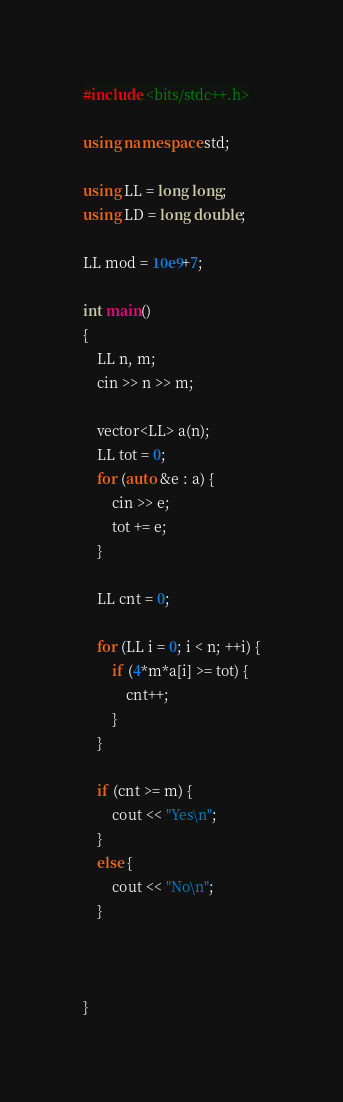Convert code to text. <code><loc_0><loc_0><loc_500><loc_500><_C++_>#include <bits/stdc++.h>
 
using namespace std;

using LL = long long;
using LD = long double;
 
LL mod = 10e9+7;

int main()
{
	LL n, m;
	cin >> n >> m;

	vector<LL> a(n);
	LL tot = 0;
	for (auto &e : a) {
		cin >> e;
		tot += e;
	}

	LL cnt = 0;

	for (LL i = 0; i < n; ++i) {
		if (4*m*a[i] >= tot) {
			cnt++;
		}
	}

	if (cnt >= m) {
		cout << "Yes\n";
	}
	else {
		cout << "No\n";
	}



}</code> 